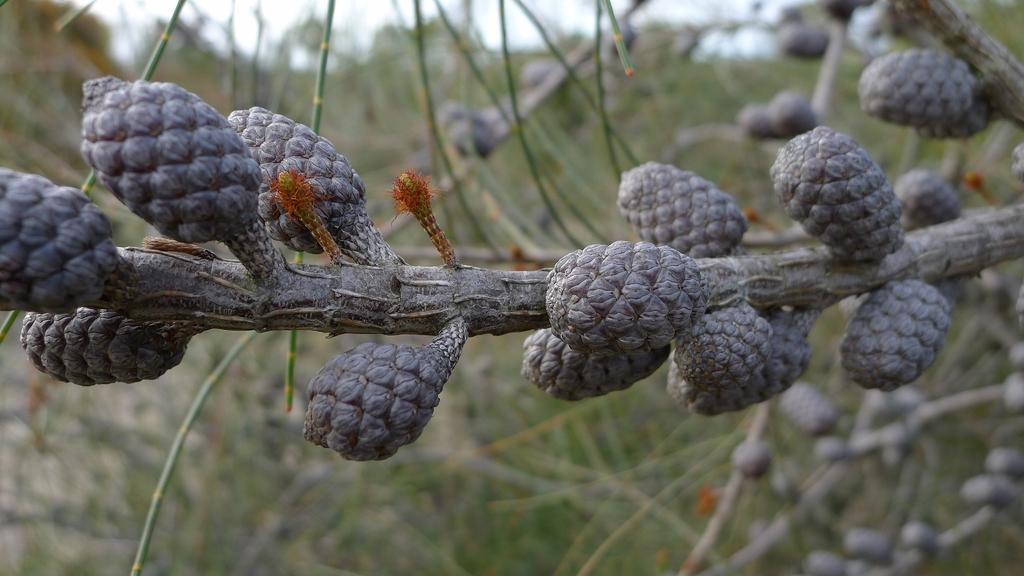What is the main subject of the image? The main subject of the image is a stem with cones. Can you describe the background of the image? The background of the image is blurred. What type of club is visible in the image? There is no club present in the image; it features a stem with cones and a blurred background. How many masses can be seen in the image? There is no mass present in the image; it features a stem with cones and a blurred background. 